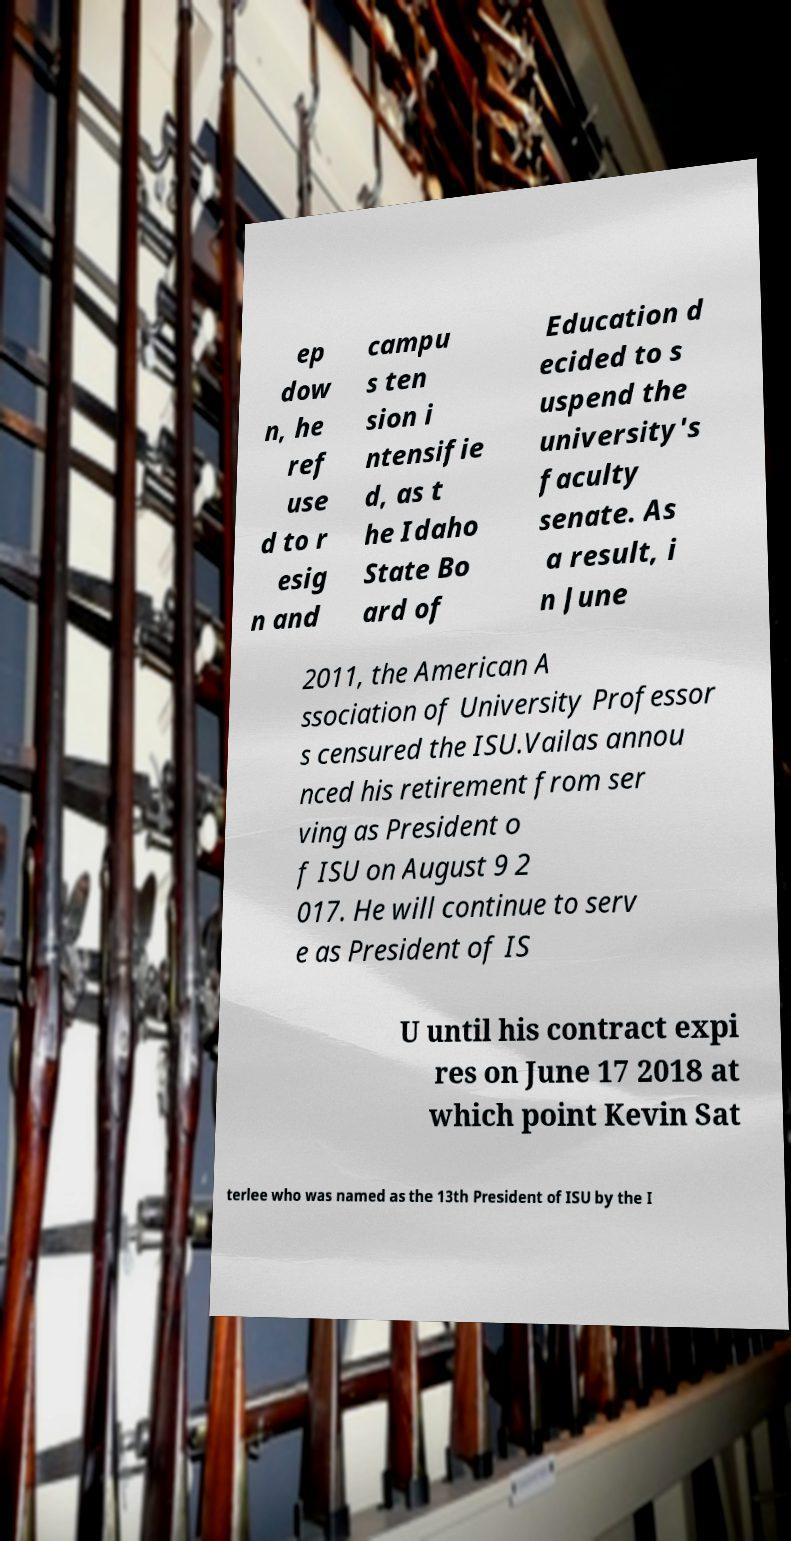For documentation purposes, I need the text within this image transcribed. Could you provide that? ep dow n, he ref use d to r esig n and campu s ten sion i ntensifie d, as t he Idaho State Bo ard of Education d ecided to s uspend the university's faculty senate. As a result, i n June 2011, the American A ssociation of University Professor s censured the ISU.Vailas annou nced his retirement from ser ving as President o f ISU on August 9 2 017. He will continue to serv e as President of IS U until his contract expi res on June 17 2018 at which point Kevin Sat terlee who was named as the 13th President of ISU by the I 